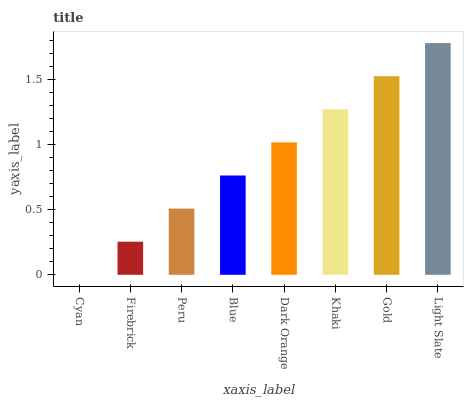Is Firebrick the minimum?
Answer yes or no. No. Is Firebrick the maximum?
Answer yes or no. No. Is Firebrick greater than Cyan?
Answer yes or no. Yes. Is Cyan less than Firebrick?
Answer yes or no. Yes. Is Cyan greater than Firebrick?
Answer yes or no. No. Is Firebrick less than Cyan?
Answer yes or no. No. Is Dark Orange the high median?
Answer yes or no. Yes. Is Blue the low median?
Answer yes or no. Yes. Is Khaki the high median?
Answer yes or no. No. Is Khaki the low median?
Answer yes or no. No. 